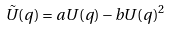Convert formula to latex. <formula><loc_0><loc_0><loc_500><loc_500>\tilde { U } ( q ) = a U ( q ) - b U ( q ) ^ { 2 }</formula> 